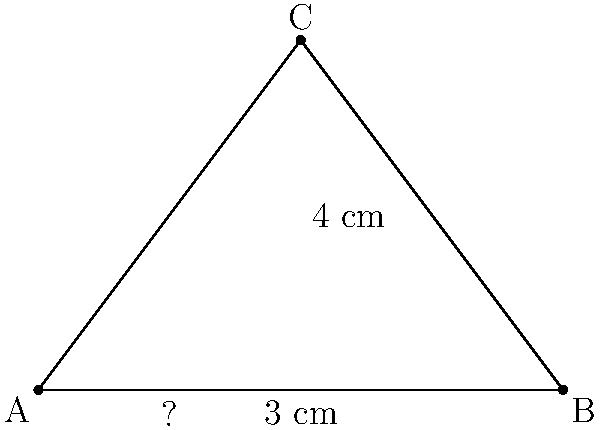In a partially damaged early Christian cross symbol, only the right half remains intact. The preserved vertical arm measures 4 cm, and half of the horizontal arm measures 3 cm. Assuming the cross was originally symmetrical, what was the total length of the horizontal arm before the damage occurred? To solve this problem, we can use the properties of right triangles and the Pythagorean theorem. Let's approach this step-by-step:

1) The preserved part of the cross forms a right triangle. We know two sides of this triangle:
   - The vertical arm (height) is 4 cm
   - Half of the horizontal arm (base) is 3 cm

2) Let's call the length of the full horizontal arm $2x$ (since 3 cm is half of it).

3) We can use the Pythagorean theorem to set up an equation:
   $x^2 + 4^2 = (x+3)^2$

4) Expand the equation:
   $x^2 + 16 = x^2 + 6x + 9$

5) Simplify by subtracting $x^2$ from both sides:
   $16 = 6x + 9$

6) Subtract 9 from both sides:
   $7 = 6x$

7) Divide both sides by 6:
   $\frac{7}{6} = x$

8) Remember, this is half of the horizontal arm. The full length is $2x$:
   $2x = 2 * \frac{7}{6} = \frac{14}{6} = \frac{7}{3} \approx 2.33$ cm

Therefore, the total length of the horizontal arm before damage was $\frac{7}{3}$ cm or approximately 2.33 cm.
Answer: $\frac{7}{3}$ cm 